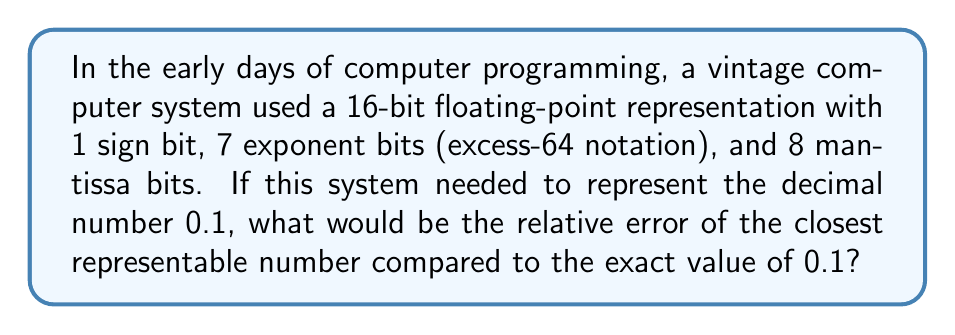Solve this math problem. To solve this problem, we need to follow these steps:

1) First, let's convert 0.1 to binary:
   $0.1_{10} = 0.0001100110011001100..._2$ (repeating)

2) In the given floating-point format, this would be represented as:
   Sign bit: 0 (positive)
   Exponent: $64 - 3 = 61$ (because we need to shift 3 places to the right)
   Mantissa: The first 8 bits after the leading 1, which is 10011001

3) So the representation would be:
   $0 \, 0111101 \, 10011001$

4) To convert this back to decimal:
   $(-1)^0 \times 1.10011001_2 \times 2^{-3}$

5) Let's calculate $1.10011001_2$:
   $1 + \frac{1}{2} + \frac{1}{16} + \frac{1}{32} + \frac{1}{256} = 1.59765625$

6) So the represented number is:
   $1.59765625 \times 2^{-3} = 0.1998291015625$

7) Now we can calculate the relative error:
   $$\text{Relative Error} = \left|\frac{\text{Approximate Value} - \text{Exact Value}}{\text{Exact Value}}\right|$$
   $$= \left|\frac{0.1998291015625 - 0.1}{0.1}\right|$$
   $$= \left|\frac{0.0998291015625}{0.1}\right|$$
   $$= 0.0998291015625$$

8) To express as a percentage:
   $0.0998291015625 \times 100\% = 9.98291015625\%$
Answer: The relative error is approximately 9.98%. 